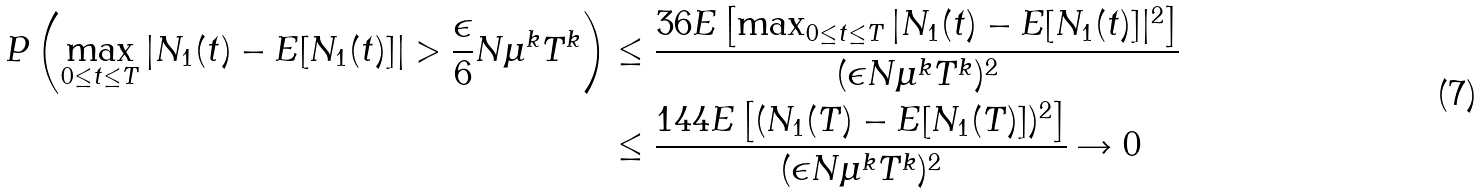<formula> <loc_0><loc_0><loc_500><loc_500>P \left ( \max _ { 0 \leq t \leq T } \left | N _ { 1 } ( t ) - E [ N _ { 1 } ( t ) ] \right | > \frac { \epsilon } { 6 } N \mu ^ { k } T ^ { k } \right ) & \leq \frac { 3 6 E \left [ \max _ { 0 \leq t \leq T } | N _ { 1 } ( t ) - E [ N _ { 1 } ( t ) ] | ^ { 2 } \right ] } { ( \epsilon N \mu ^ { k } T ^ { k } ) ^ { 2 } } \\ & \leq \frac { 1 4 4 E \left [ ( N _ { 1 } ( T ) - E [ N _ { 1 } ( T ) ] ) ^ { 2 } \right ] } { ( \epsilon N \mu ^ { k } T ^ { k } ) ^ { 2 } } \rightarrow 0</formula> 